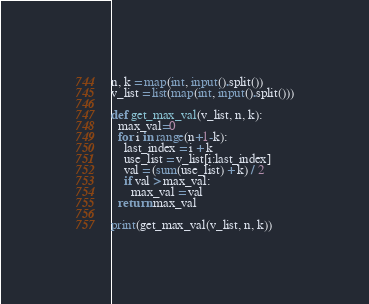Convert code to text. <code><loc_0><loc_0><loc_500><loc_500><_Python_>n, k = map(int, input().split())
v_list = list(map(int, input().split()))

def get_max_val(v_list, n, k):
  max_val=0
  for i in range(n+1-k):
    last_index = i + k
    use_list = v_list[i:last_index]
    val = (sum(use_list) + k) / 2
    if val > max_val:
      max_val = val
  return max_val
  
print(get_max_val(v_list, n, k))</code> 